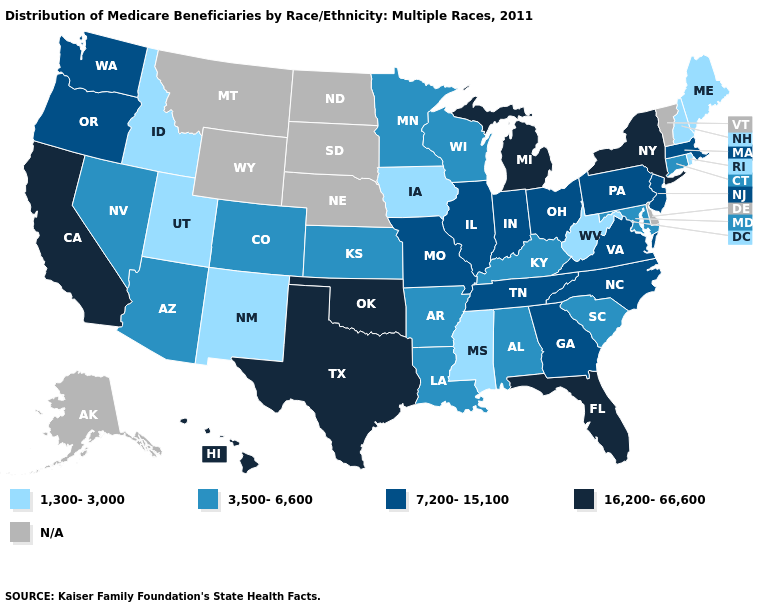Does California have the highest value in the West?
Quick response, please. Yes. What is the lowest value in the USA?
Keep it brief. 1,300-3,000. What is the value of Connecticut?
Answer briefly. 3,500-6,600. What is the value of New York?
Write a very short answer. 16,200-66,600. Among the states that border Florida , which have the highest value?
Quick response, please. Georgia. What is the value of North Dakota?
Give a very brief answer. N/A. What is the value of New York?
Short answer required. 16,200-66,600. What is the value of Wisconsin?
Give a very brief answer. 3,500-6,600. Does Michigan have the highest value in the MidWest?
Concise answer only. Yes. What is the lowest value in the USA?
Answer briefly. 1,300-3,000. What is the value of Maine?
Write a very short answer. 1,300-3,000. What is the value of Arizona?
Keep it brief. 3,500-6,600. What is the value of Kentucky?
Answer briefly. 3,500-6,600. Among the states that border Iowa , which have the lowest value?
Concise answer only. Minnesota, Wisconsin. What is the lowest value in the USA?
Be succinct. 1,300-3,000. 